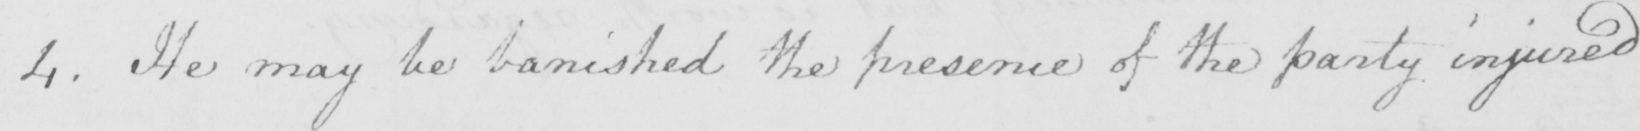Can you read and transcribe this handwriting? 4 . He may be banished the presence of the party injured 